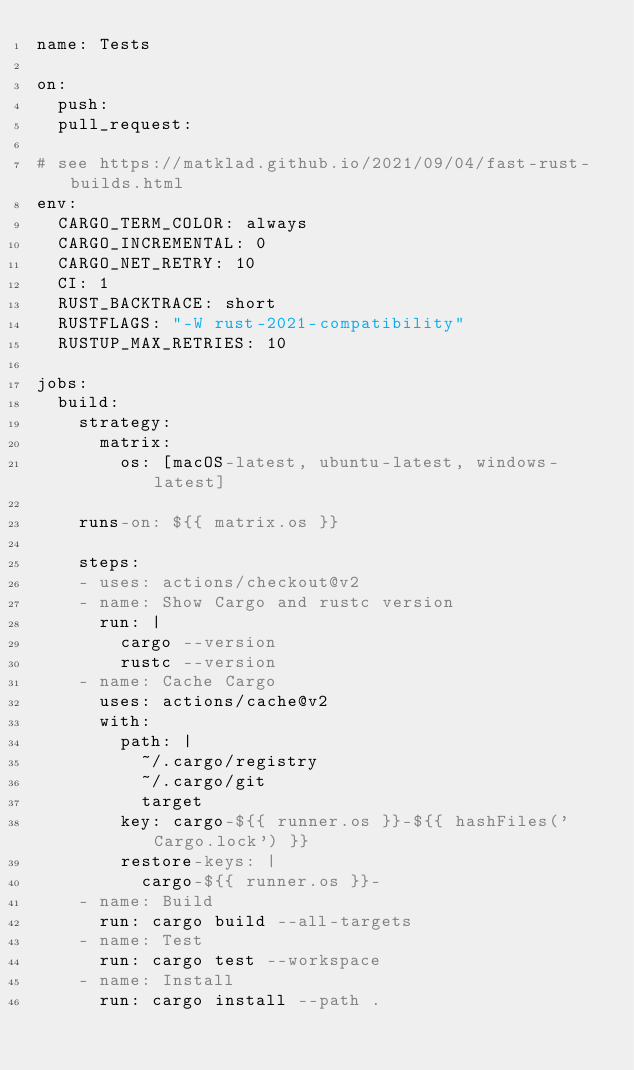Convert code to text. <code><loc_0><loc_0><loc_500><loc_500><_YAML_>name: Tests

on:
  push:
  pull_request:

# see https://matklad.github.io/2021/09/04/fast-rust-builds.html
env:
  CARGO_TERM_COLOR: always
  CARGO_INCREMENTAL: 0
  CARGO_NET_RETRY: 10
  CI: 1
  RUST_BACKTRACE: short
  RUSTFLAGS: "-W rust-2021-compatibility"
  RUSTUP_MAX_RETRIES: 10

jobs:
  build:
    strategy:
      matrix:
        os: [macOS-latest, ubuntu-latest, windows-latest]

    runs-on: ${{ matrix.os }}

    steps:
    - uses: actions/checkout@v2
    - name: Show Cargo and rustc version
      run: |
        cargo --version
        rustc --version
    - name: Cache Cargo
      uses: actions/cache@v2
      with:
        path: |
          ~/.cargo/registry
          ~/.cargo/git
          target
        key: cargo-${{ runner.os }}-${{ hashFiles('Cargo.lock') }}
        restore-keys: |
          cargo-${{ runner.os }}-
    - name: Build
      run: cargo build --all-targets
    - name: Test
      run: cargo test --workspace
    - name: Install
      run: cargo install --path .

</code> 